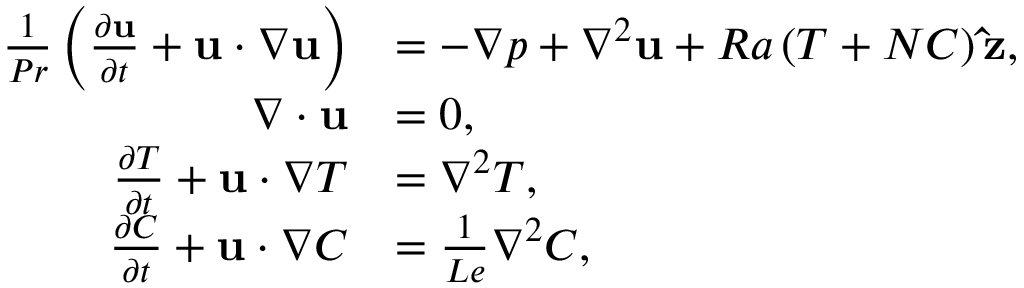<formula> <loc_0><loc_0><loc_500><loc_500>\begin{array} { r l } { \frac { 1 } { P r } \left ( \frac { \partial u } { \partial t } + u \cdot \nabla u \right ) } & { = - \nabla p + \nabla ^ { 2 } u + R a \left ( T + N C \right ) \hat { z } , } \\ { \nabla \cdot u } & { = 0 , } \\ { \frac { \partial T } { \partial t } + u \cdot \nabla T } & { = \nabla ^ { 2 } T , } \\ { \frac { \partial C } { \partial t } + u \cdot \nabla C } & { = \frac { 1 } { L e } \nabla ^ { 2 } C , } \end{array}</formula> 